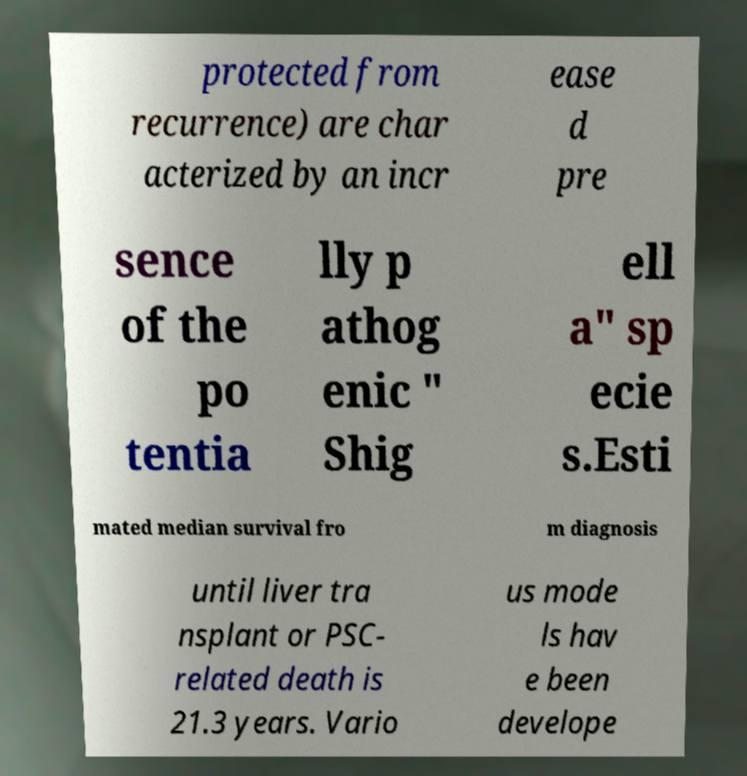Please identify and transcribe the text found in this image. protected from recurrence) are char acterized by an incr ease d pre sence of the po tentia lly p athog enic " Shig ell a" sp ecie s.Esti mated median survival fro m diagnosis until liver tra nsplant or PSC- related death is 21.3 years. Vario us mode ls hav e been develope 